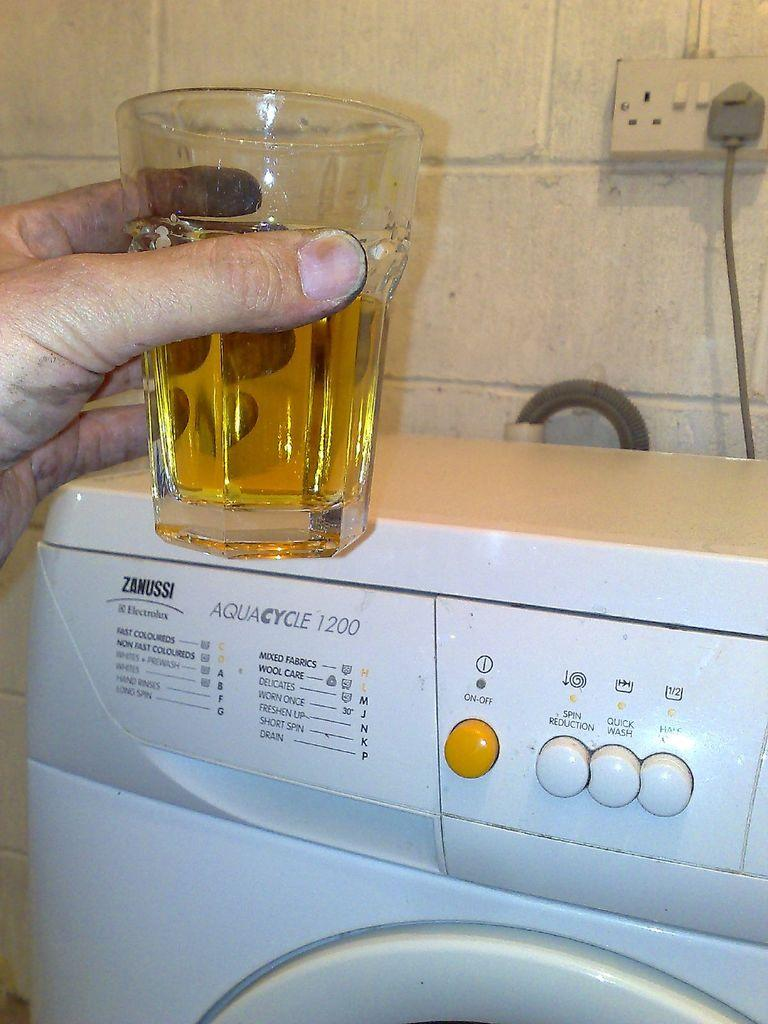<image>
Offer a succinct explanation of the picture presented. Someone holds their drink near an Aquacycle 1200 washing machine. 